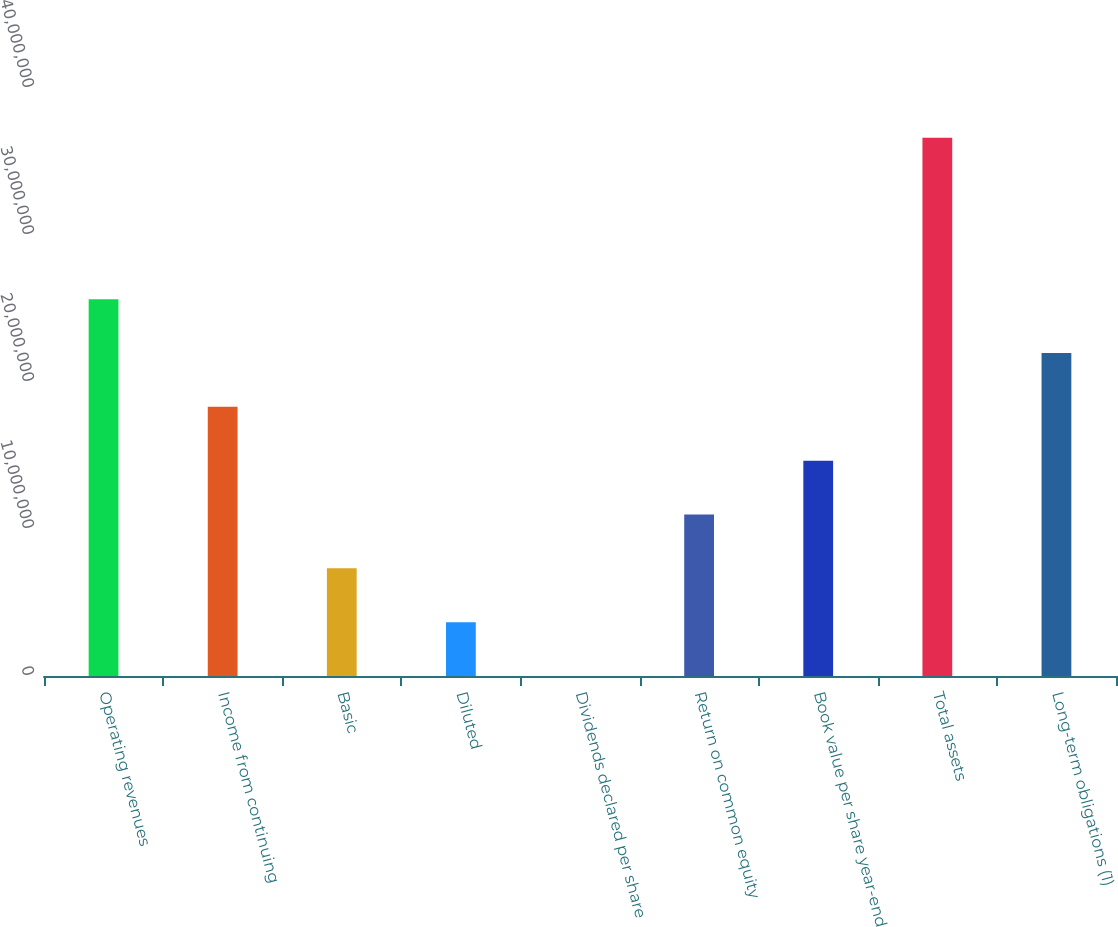<chart> <loc_0><loc_0><loc_500><loc_500><bar_chart><fcel>Operating revenues<fcel>Income from continuing<fcel>Basic<fcel>Diluted<fcel>Dividends declared per share<fcel>Return on common equity<fcel>Book value per share year-end<fcel>Total assets<fcel>Long-term obligations (1)<nl><fcel>2.56318e+07<fcel>1.83084e+07<fcel>7.32337e+06<fcel>3.66168e+06<fcel>3<fcel>1.0985e+07<fcel>1.46467e+07<fcel>3.66168e+07<fcel>2.19701e+07<nl></chart> 